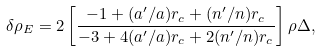Convert formula to latex. <formula><loc_0><loc_0><loc_500><loc_500>\delta \rho _ { E } = 2 \left [ \frac { - 1 + ( a ^ { \prime } / a ) r _ { c } + ( n ^ { \prime } / n ) r _ { c } } { - 3 + 4 ( a ^ { \prime } / a ) r _ { c } + 2 ( n ^ { \prime } / n ) r _ { c } } \right ] \rho \Delta ,</formula> 